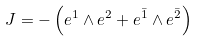Convert formula to latex. <formula><loc_0><loc_0><loc_500><loc_500>J = - \left ( e ^ { 1 } \wedge e ^ { 2 } + e ^ { \bar { 1 } } \wedge e ^ { \bar { 2 } } \right )</formula> 